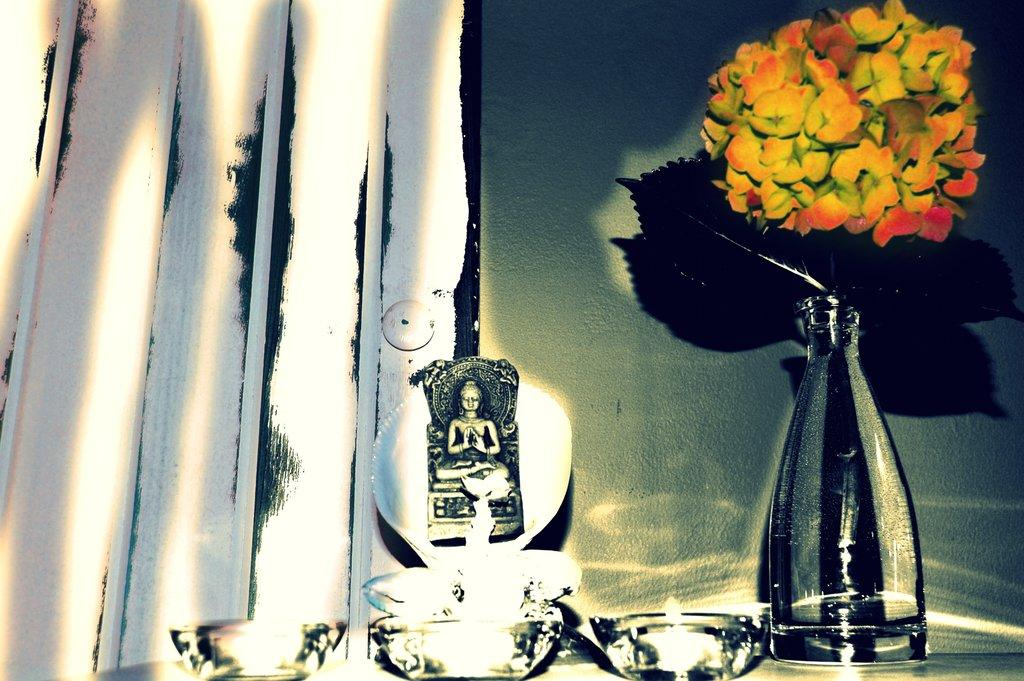What is in the pot that is visible in the image? There are flowers in a pot in the image. What other object can be seen in the image besides the flowers? There is a sculpture in the image. What colors are the flowers in the pot? The flowers have yellow and orange colors. What type of wound can be seen on the sculpture in the image? There is no wound present on the sculpture in the image. 